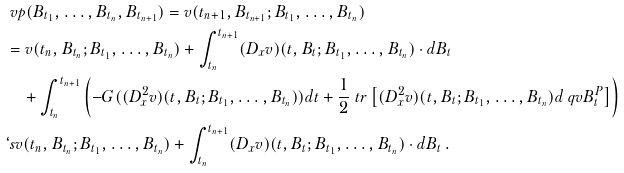Convert formula to latex. <formula><loc_0><loc_0><loc_500><loc_500>& \ v p ( B _ { t _ { 1 } } , \dots , B _ { t _ { n } } , B _ { t _ { n + 1 } } ) = v ( t _ { n + 1 } , B _ { t _ { n + 1 } } ; B _ { t _ { 1 } } , \dots , B _ { t _ { n } } ) \\ & = v ( t _ { n } , B _ { t _ { n } } ; B _ { t _ { 1 } } , \dots , B _ { t _ { n } } ) + \int _ { t _ { n } } ^ { t _ { n + 1 } } ( D _ { x } v ) ( t , B _ { t } ; B _ { t _ { 1 } } , \dots , B _ { t _ { n } } ) \cdot d B _ { t } \\ & \quad + \int _ { t _ { n } } ^ { t _ { n + 1 } } \left ( - G ( ( D _ { x } ^ { 2 } v ) ( t , B _ { t } ; B _ { t _ { 1 } } , \dots , B _ { t _ { n } } ) ) d t + \frac { 1 } { 2 } \ t r \left [ ( D _ { x } ^ { 2 } v ) ( t , B _ { t } ; B _ { t _ { 1 } } , \dots , B _ { t _ { n } } ) d \ q v { B } ^ { P } _ { t } \right ] \right ) \\ & \lq s v ( t _ { n } , B _ { t _ { n } } ; B _ { t _ { 1 } } , \dots , B _ { t _ { n } } ) + \int _ { t _ { n } } ^ { t _ { n + 1 } } ( D _ { x } v ) ( t , B _ { t } ; B _ { t _ { 1 } } , \dots , B _ { t _ { n } } ) \cdot d B _ { t } \, .</formula> 